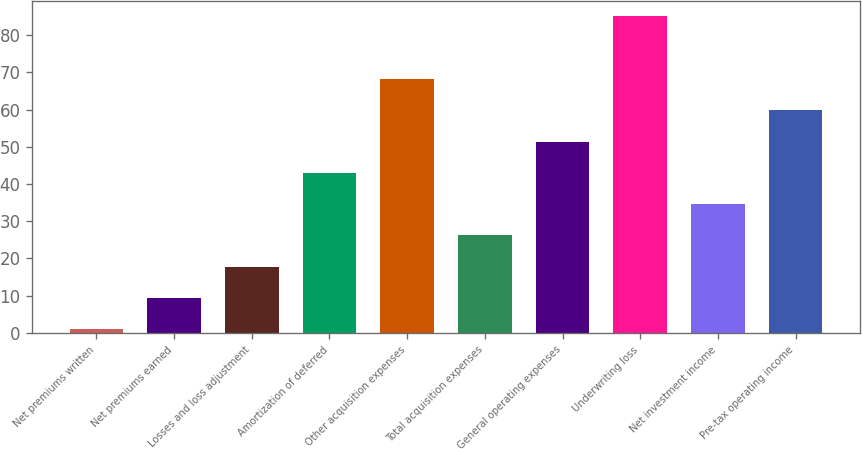Convert chart. <chart><loc_0><loc_0><loc_500><loc_500><bar_chart><fcel>Net premiums written<fcel>Net premiums earned<fcel>Losses and loss adjustment<fcel>Amortization of deferred<fcel>Other acquisition expenses<fcel>Total acquisition expenses<fcel>General operating expenses<fcel>Underwriting loss<fcel>Net investment income<fcel>Pre-tax operating income<nl><fcel>1<fcel>9.4<fcel>17.8<fcel>43<fcel>68.2<fcel>26.2<fcel>51.4<fcel>85<fcel>34.6<fcel>59.8<nl></chart> 